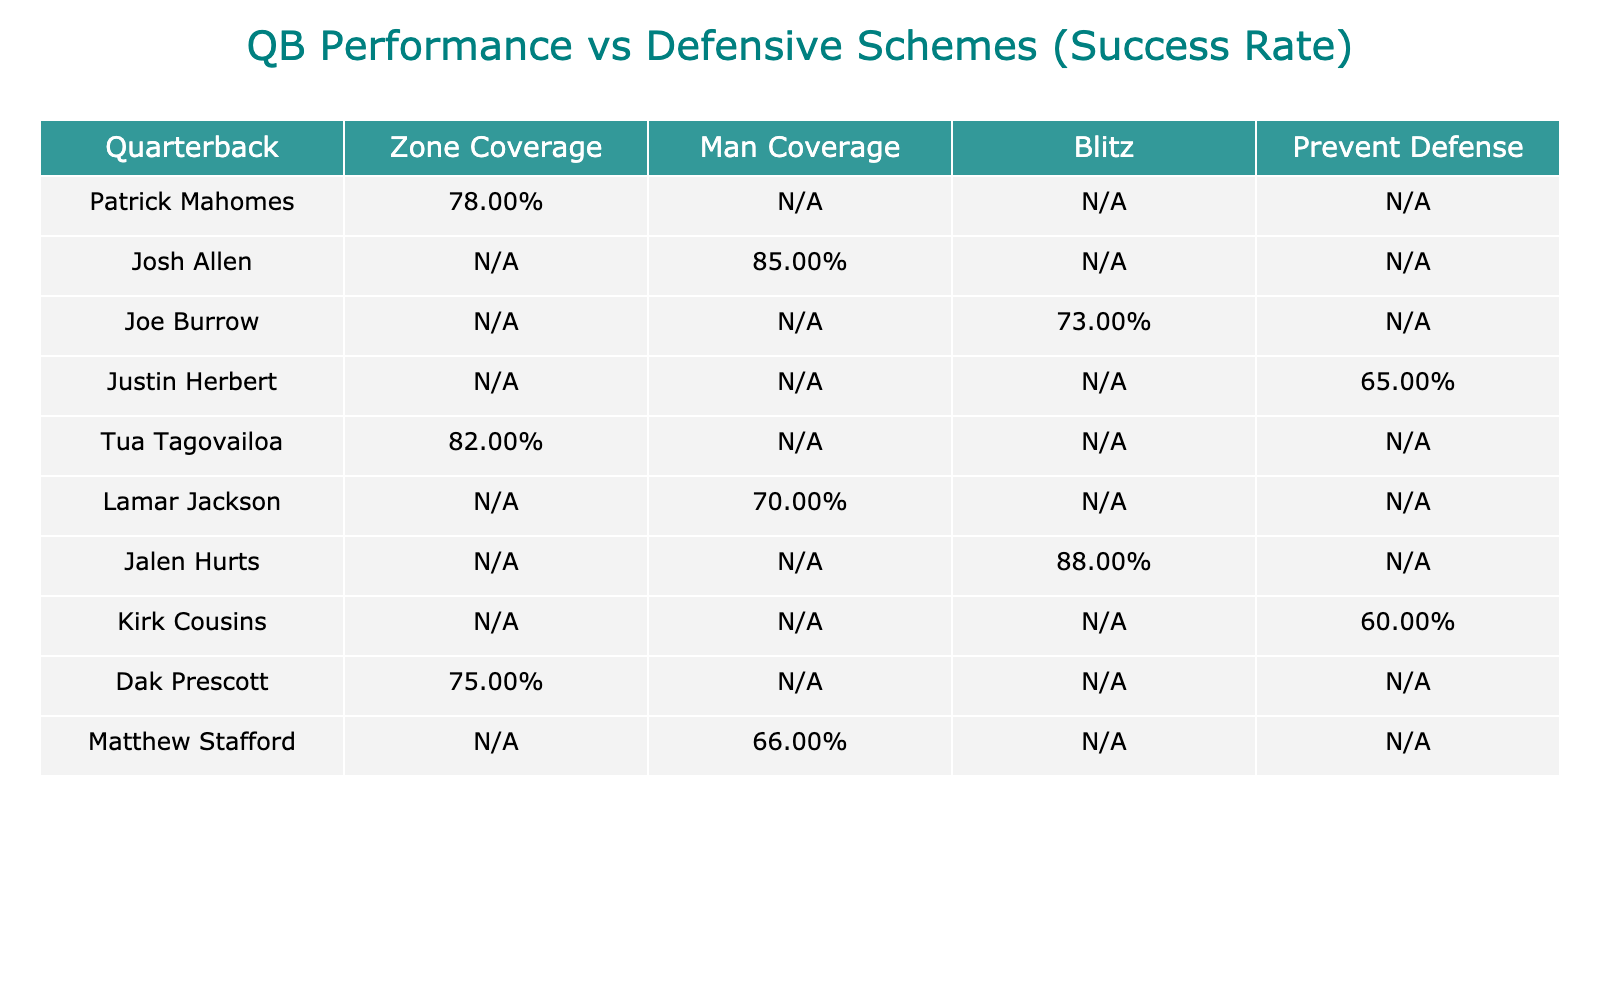What is the success rate of Patrick Mahomes against Zone Coverage? Patrick Mahomes has a success rate of 78 successful plays out of 100 total plays (78 successful plays + 22 unsuccessful plays), which calculates to a success rate of 78%.
Answer: 78% Which quarterback performed the best against Man Coverage? Josh Allen achieved the highest success rate against Man Coverage with 85 successful plays out of 100 total plays (85 successful plays + 15 unsuccessful plays), resulting in a success rate of 85%.
Answer: 85% How many quarterbacks had a success rate above 75% against Zone Coverage? The quarterbacks with a success rate above 75% against Zone Coverage are Patrick Mahomes (78%), Tua Tagovailoa (82%), and Dak Prescott (75%). Therefore, there are three quarterbacks in total.
Answer: 3 Is there any quarterback who had a lower success rate against Blitz compared to other schemes? Yes, Joe Burrow had a success rate of 73% against Blitz. Jalen Hurts had a higher success rate of 88% against the same scheme, making Burrow's performance the lowest compared to other quarterbacks in the table when facing blitz defenses.
Answer: Yes What is the average success rate of quarterbacks against Prevent Defense? To find the average, we take the success rates for Justin Herbert (65%) and Kirk Cousins (60%). Adding them gives a total of 125% (65 + 60), and dividing by the number of quarterbacks (2) results in an average of 62.5%.
Answer: 62.5% 